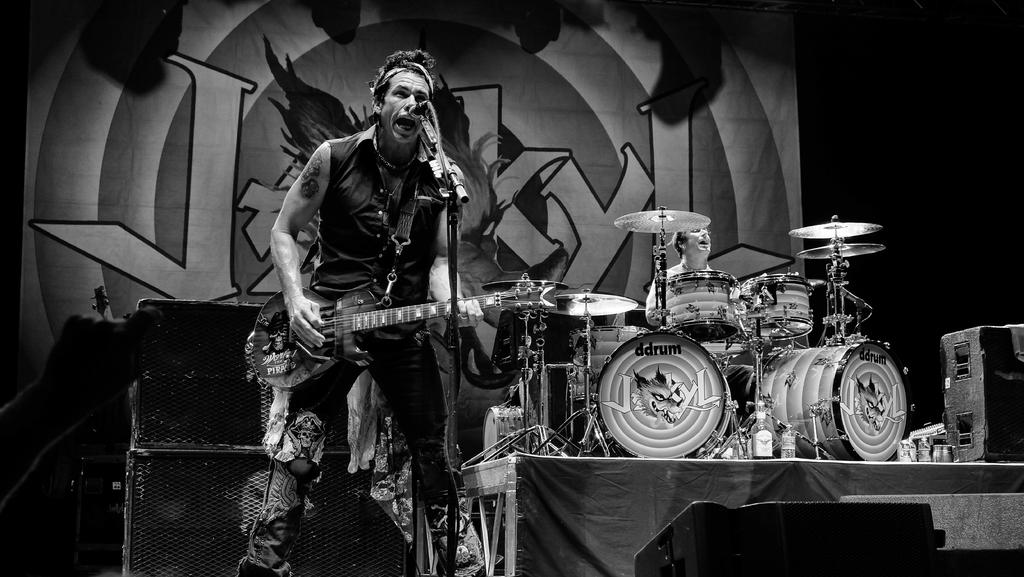What is the main activity of the person in the image? There is a man playing guitar in the image. What object is present that is typically used for amplifying sound? There is a speaker in the image. What other musical instrument can be seen in the background? There is a man playing a band instrument in the background. What object is present that is typically used for amplifying the voice? There is a microphone in the image. How many pets are visible in the image? There are no pets present in the image. What type of health supplements can be seen in the image? There are no health supplements present in the image. 